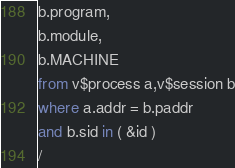<code> <loc_0><loc_0><loc_500><loc_500><_SQL_>b.program,
b.module,
b.MACHINE
from v$process a,v$session b
where a.addr = b.paddr
and b.sid in ( &id )
/</code> 